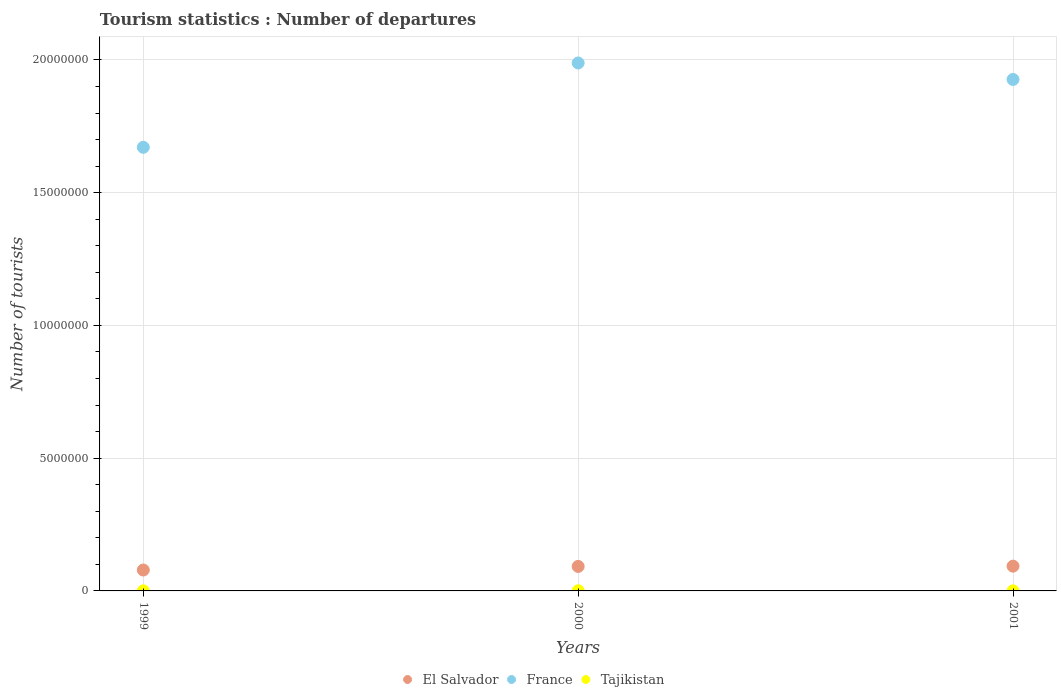How many different coloured dotlines are there?
Provide a succinct answer. 3. Is the number of dotlines equal to the number of legend labels?
Your answer should be very brief. Yes. What is the number of tourist departures in France in 2000?
Your response must be concise. 1.99e+07. Across all years, what is the maximum number of tourist departures in Tajikistan?
Make the answer very short. 6400. Across all years, what is the minimum number of tourist departures in France?
Provide a succinct answer. 1.67e+07. In which year was the number of tourist departures in France maximum?
Offer a very short reply. 2000. What is the total number of tourist departures in France in the graph?
Your response must be concise. 5.59e+07. What is the difference between the number of tourist departures in El Salvador in 1999 and that in 2001?
Your response must be concise. -1.46e+05. What is the difference between the number of tourist departures in El Salvador in 1999 and the number of tourist departures in Tajikistan in 2000?
Give a very brief answer. 7.81e+05. What is the average number of tourist departures in El Salvador per year?
Provide a short and direct response. 8.81e+05. In the year 1999, what is the difference between the number of tourist departures in El Salvador and number of tourist departures in France?
Give a very brief answer. -1.59e+07. In how many years, is the number of tourist departures in Tajikistan greater than 8000000?
Give a very brief answer. 0. What is the ratio of the number of tourist departures in El Salvador in 2000 to that in 2001?
Make the answer very short. 0.99. Is the number of tourist departures in El Salvador in 1999 less than that in 2000?
Offer a very short reply. Yes. Is the difference between the number of tourist departures in El Salvador in 1999 and 2001 greater than the difference between the number of tourist departures in France in 1999 and 2001?
Your response must be concise. Yes. What is the difference between the highest and the second highest number of tourist departures in Tajikistan?
Your answer should be compact. 2300. What is the difference between the highest and the lowest number of tourist departures in Tajikistan?
Offer a very short reply. 3700. Is it the case that in every year, the sum of the number of tourist departures in El Salvador and number of tourist departures in France  is greater than the number of tourist departures in Tajikistan?
Your answer should be very brief. Yes. Does the number of tourist departures in Tajikistan monotonically increase over the years?
Ensure brevity in your answer.  No. Is the number of tourist departures in Tajikistan strictly greater than the number of tourist departures in France over the years?
Offer a terse response. No. How many dotlines are there?
Make the answer very short. 3. Are the values on the major ticks of Y-axis written in scientific E-notation?
Your answer should be very brief. No. Does the graph contain any zero values?
Provide a succinct answer. No. Does the graph contain grids?
Make the answer very short. Yes. How many legend labels are there?
Give a very brief answer. 3. How are the legend labels stacked?
Your response must be concise. Horizontal. What is the title of the graph?
Provide a succinct answer. Tourism statistics : Number of departures. What is the label or title of the Y-axis?
Ensure brevity in your answer.  Number of tourists. What is the Number of tourists of El Salvador in 1999?
Offer a terse response. 7.87e+05. What is the Number of tourists of France in 1999?
Provide a short and direct response. 1.67e+07. What is the Number of tourists in Tajikistan in 1999?
Make the answer very short. 4100. What is the Number of tourists of El Salvador in 2000?
Make the answer very short. 9.23e+05. What is the Number of tourists in France in 2000?
Ensure brevity in your answer.  1.99e+07. What is the Number of tourists in Tajikistan in 2000?
Your response must be concise. 6400. What is the Number of tourists in El Salvador in 2001?
Offer a terse response. 9.33e+05. What is the Number of tourists of France in 2001?
Offer a terse response. 1.93e+07. What is the Number of tourists of Tajikistan in 2001?
Your answer should be compact. 2700. Across all years, what is the maximum Number of tourists in El Salvador?
Ensure brevity in your answer.  9.33e+05. Across all years, what is the maximum Number of tourists in France?
Provide a succinct answer. 1.99e+07. Across all years, what is the maximum Number of tourists in Tajikistan?
Make the answer very short. 6400. Across all years, what is the minimum Number of tourists in El Salvador?
Make the answer very short. 7.87e+05. Across all years, what is the minimum Number of tourists in France?
Offer a terse response. 1.67e+07. Across all years, what is the minimum Number of tourists of Tajikistan?
Offer a very short reply. 2700. What is the total Number of tourists in El Salvador in the graph?
Offer a very short reply. 2.64e+06. What is the total Number of tourists in France in the graph?
Your answer should be compact. 5.59e+07. What is the total Number of tourists of Tajikistan in the graph?
Keep it short and to the point. 1.32e+04. What is the difference between the Number of tourists in El Salvador in 1999 and that in 2000?
Provide a succinct answer. -1.36e+05. What is the difference between the Number of tourists of France in 1999 and that in 2000?
Your answer should be compact. -3.18e+06. What is the difference between the Number of tourists in Tajikistan in 1999 and that in 2000?
Keep it short and to the point. -2300. What is the difference between the Number of tourists of El Salvador in 1999 and that in 2001?
Offer a very short reply. -1.46e+05. What is the difference between the Number of tourists in France in 1999 and that in 2001?
Keep it short and to the point. -2.56e+06. What is the difference between the Number of tourists of Tajikistan in 1999 and that in 2001?
Provide a succinct answer. 1400. What is the difference between the Number of tourists of El Salvador in 2000 and that in 2001?
Your answer should be compact. -10000. What is the difference between the Number of tourists of France in 2000 and that in 2001?
Offer a terse response. 6.21e+05. What is the difference between the Number of tourists in Tajikistan in 2000 and that in 2001?
Give a very brief answer. 3700. What is the difference between the Number of tourists of El Salvador in 1999 and the Number of tourists of France in 2000?
Provide a short and direct response. -1.91e+07. What is the difference between the Number of tourists in El Salvador in 1999 and the Number of tourists in Tajikistan in 2000?
Ensure brevity in your answer.  7.81e+05. What is the difference between the Number of tourists in France in 1999 and the Number of tourists in Tajikistan in 2000?
Give a very brief answer. 1.67e+07. What is the difference between the Number of tourists of El Salvador in 1999 and the Number of tourists of France in 2001?
Give a very brief answer. -1.85e+07. What is the difference between the Number of tourists of El Salvador in 1999 and the Number of tourists of Tajikistan in 2001?
Give a very brief answer. 7.84e+05. What is the difference between the Number of tourists in France in 1999 and the Number of tourists in Tajikistan in 2001?
Give a very brief answer. 1.67e+07. What is the difference between the Number of tourists in El Salvador in 2000 and the Number of tourists in France in 2001?
Offer a terse response. -1.83e+07. What is the difference between the Number of tourists in El Salvador in 2000 and the Number of tourists in Tajikistan in 2001?
Make the answer very short. 9.20e+05. What is the difference between the Number of tourists in France in 2000 and the Number of tourists in Tajikistan in 2001?
Make the answer very short. 1.99e+07. What is the average Number of tourists in El Salvador per year?
Ensure brevity in your answer.  8.81e+05. What is the average Number of tourists in France per year?
Offer a terse response. 1.86e+07. What is the average Number of tourists in Tajikistan per year?
Your answer should be very brief. 4400. In the year 1999, what is the difference between the Number of tourists of El Salvador and Number of tourists of France?
Your response must be concise. -1.59e+07. In the year 1999, what is the difference between the Number of tourists in El Salvador and Number of tourists in Tajikistan?
Provide a short and direct response. 7.83e+05. In the year 1999, what is the difference between the Number of tourists of France and Number of tourists of Tajikistan?
Provide a succinct answer. 1.67e+07. In the year 2000, what is the difference between the Number of tourists in El Salvador and Number of tourists in France?
Offer a terse response. -1.90e+07. In the year 2000, what is the difference between the Number of tourists in El Salvador and Number of tourists in Tajikistan?
Offer a terse response. 9.17e+05. In the year 2000, what is the difference between the Number of tourists in France and Number of tourists in Tajikistan?
Provide a succinct answer. 1.99e+07. In the year 2001, what is the difference between the Number of tourists in El Salvador and Number of tourists in France?
Your answer should be compact. -1.83e+07. In the year 2001, what is the difference between the Number of tourists in El Salvador and Number of tourists in Tajikistan?
Your answer should be compact. 9.30e+05. In the year 2001, what is the difference between the Number of tourists of France and Number of tourists of Tajikistan?
Your answer should be very brief. 1.93e+07. What is the ratio of the Number of tourists in El Salvador in 1999 to that in 2000?
Your answer should be very brief. 0.85. What is the ratio of the Number of tourists of France in 1999 to that in 2000?
Offer a terse response. 0.84. What is the ratio of the Number of tourists of Tajikistan in 1999 to that in 2000?
Provide a short and direct response. 0.64. What is the ratio of the Number of tourists of El Salvador in 1999 to that in 2001?
Give a very brief answer. 0.84. What is the ratio of the Number of tourists in France in 1999 to that in 2001?
Your answer should be compact. 0.87. What is the ratio of the Number of tourists of Tajikistan in 1999 to that in 2001?
Offer a terse response. 1.52. What is the ratio of the Number of tourists in El Salvador in 2000 to that in 2001?
Ensure brevity in your answer.  0.99. What is the ratio of the Number of tourists in France in 2000 to that in 2001?
Your response must be concise. 1.03. What is the ratio of the Number of tourists in Tajikistan in 2000 to that in 2001?
Provide a short and direct response. 2.37. What is the difference between the highest and the second highest Number of tourists of France?
Your response must be concise. 6.21e+05. What is the difference between the highest and the second highest Number of tourists in Tajikistan?
Ensure brevity in your answer.  2300. What is the difference between the highest and the lowest Number of tourists of El Salvador?
Ensure brevity in your answer.  1.46e+05. What is the difference between the highest and the lowest Number of tourists of France?
Your answer should be compact. 3.18e+06. What is the difference between the highest and the lowest Number of tourists in Tajikistan?
Give a very brief answer. 3700. 